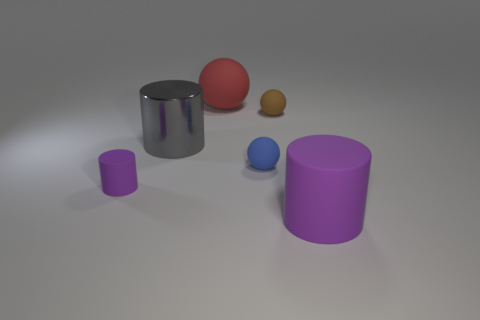Are there any tiny brown cylinders made of the same material as the tiny brown object?
Your response must be concise. No. Do the gray cylinder and the sphere that is on the right side of the blue ball have the same material?
Provide a short and direct response. No. What color is the other cylinder that is the same size as the metal cylinder?
Keep it short and to the point. Purple. What is the size of the purple matte cylinder that is right of the small object that is behind the gray cylinder?
Your answer should be compact. Large. Do the large ball and the small sphere that is behind the gray metallic thing have the same color?
Offer a very short reply. No. Are there fewer large objects that are right of the small blue matte thing than small matte things?
Offer a very short reply. Yes. What number of other objects are the same size as the blue matte object?
Your answer should be compact. 2. There is a purple rubber thing that is left of the red matte ball; is it the same shape as the brown matte thing?
Ensure brevity in your answer.  No. Is the number of small rubber balls right of the tiny blue matte thing greater than the number of large yellow spheres?
Offer a terse response. Yes. The object that is both in front of the blue ball and left of the brown matte ball is made of what material?
Make the answer very short. Rubber. 